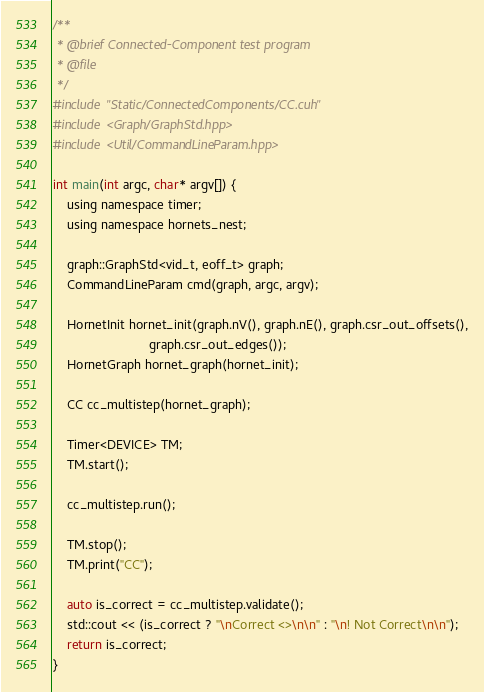Convert code to text. <code><loc_0><loc_0><loc_500><loc_500><_Cuda_>/**
 * @brief Connected-Component test program
 * @file
 */
#include "Static/ConnectedComponents/CC.cuh"
#include <Graph/GraphStd.hpp>
#include <Util/CommandLineParam.hpp>

int main(int argc, char* argv[]) {
    using namespace timer;
    using namespace hornets_nest;

    graph::GraphStd<vid_t, eoff_t> graph;
    CommandLineParam cmd(graph, argc, argv);

    HornetInit hornet_init(graph.nV(), graph.nE(), graph.csr_out_offsets(),
                           graph.csr_out_edges());
    HornetGraph hornet_graph(hornet_init);

    CC cc_multistep(hornet_graph);

    Timer<DEVICE> TM;
    TM.start();

    cc_multistep.run();

    TM.stop();
    TM.print("CC");

    auto is_correct = cc_multistep.validate();
    std::cout << (is_correct ? "\nCorrect <>\n\n" : "\n! Not Correct\n\n");
    return is_correct;
}
</code> 